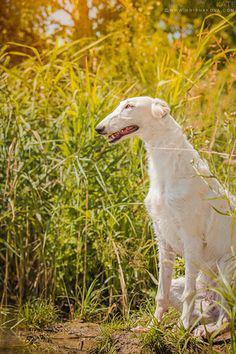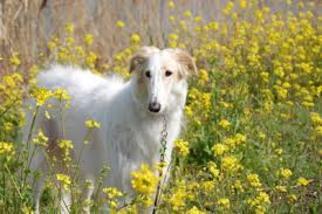The first image is the image on the left, the second image is the image on the right. For the images displayed, is the sentence "At least one dog wears a collar with no leash." factually correct? Answer yes or no. No. 